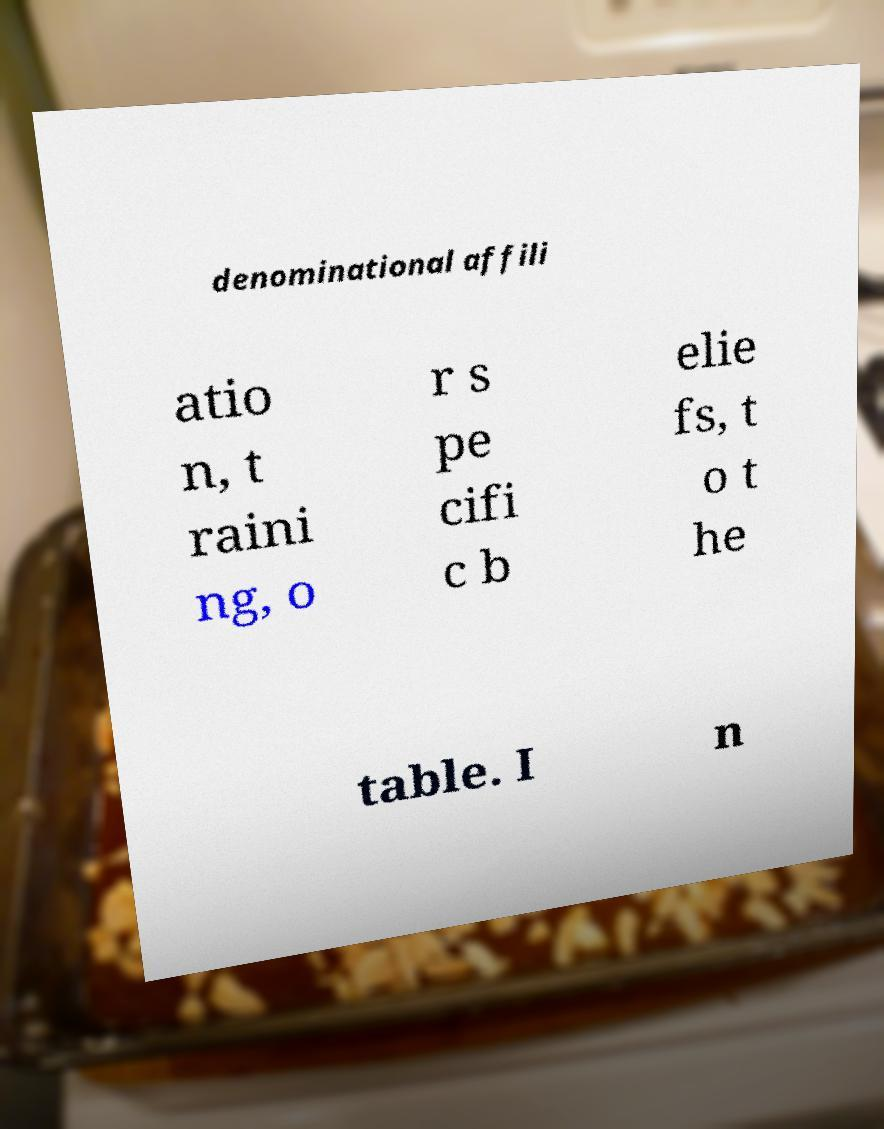Could you assist in decoding the text presented in this image and type it out clearly? denominational affili atio n, t raini ng, o r s pe cifi c b elie fs, t o t he table. I n 